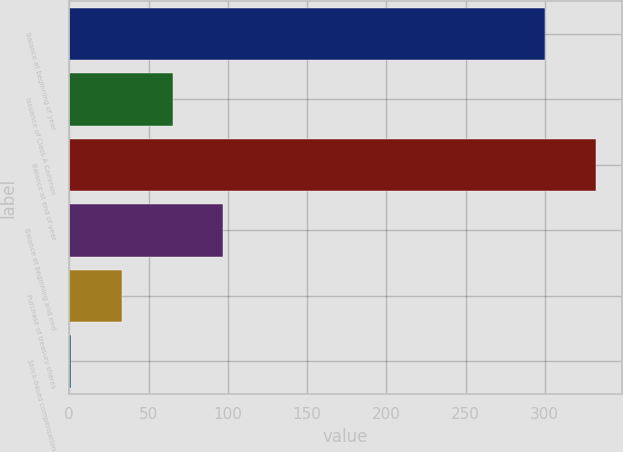Convert chart to OTSL. <chart><loc_0><loc_0><loc_500><loc_500><bar_chart><fcel>Balance at beginning of year<fcel>Issuance of Class A Common<fcel>Balance at end of year<fcel>Balance at beginning and end<fcel>Purchase of treasury shares<fcel>Stock-based compensation<nl><fcel>300<fcel>65.2<fcel>332.1<fcel>97.3<fcel>33.1<fcel>1<nl></chart> 